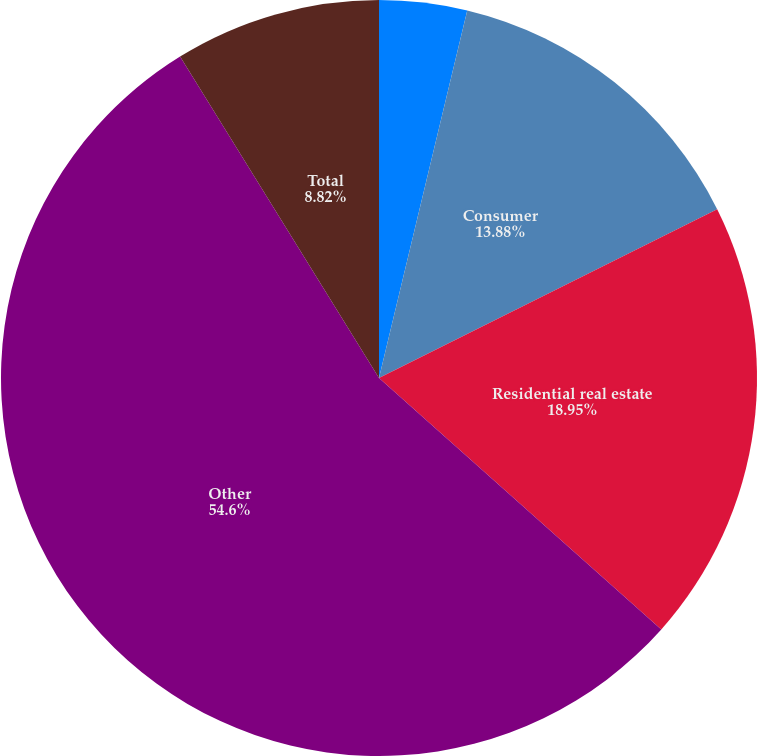Convert chart. <chart><loc_0><loc_0><loc_500><loc_500><pie_chart><fcel>Commercial real estate<fcel>Consumer<fcel>Residential real estate<fcel>Other<fcel>Total<nl><fcel>3.75%<fcel>13.88%<fcel>18.95%<fcel>54.6%<fcel>8.82%<nl></chart> 